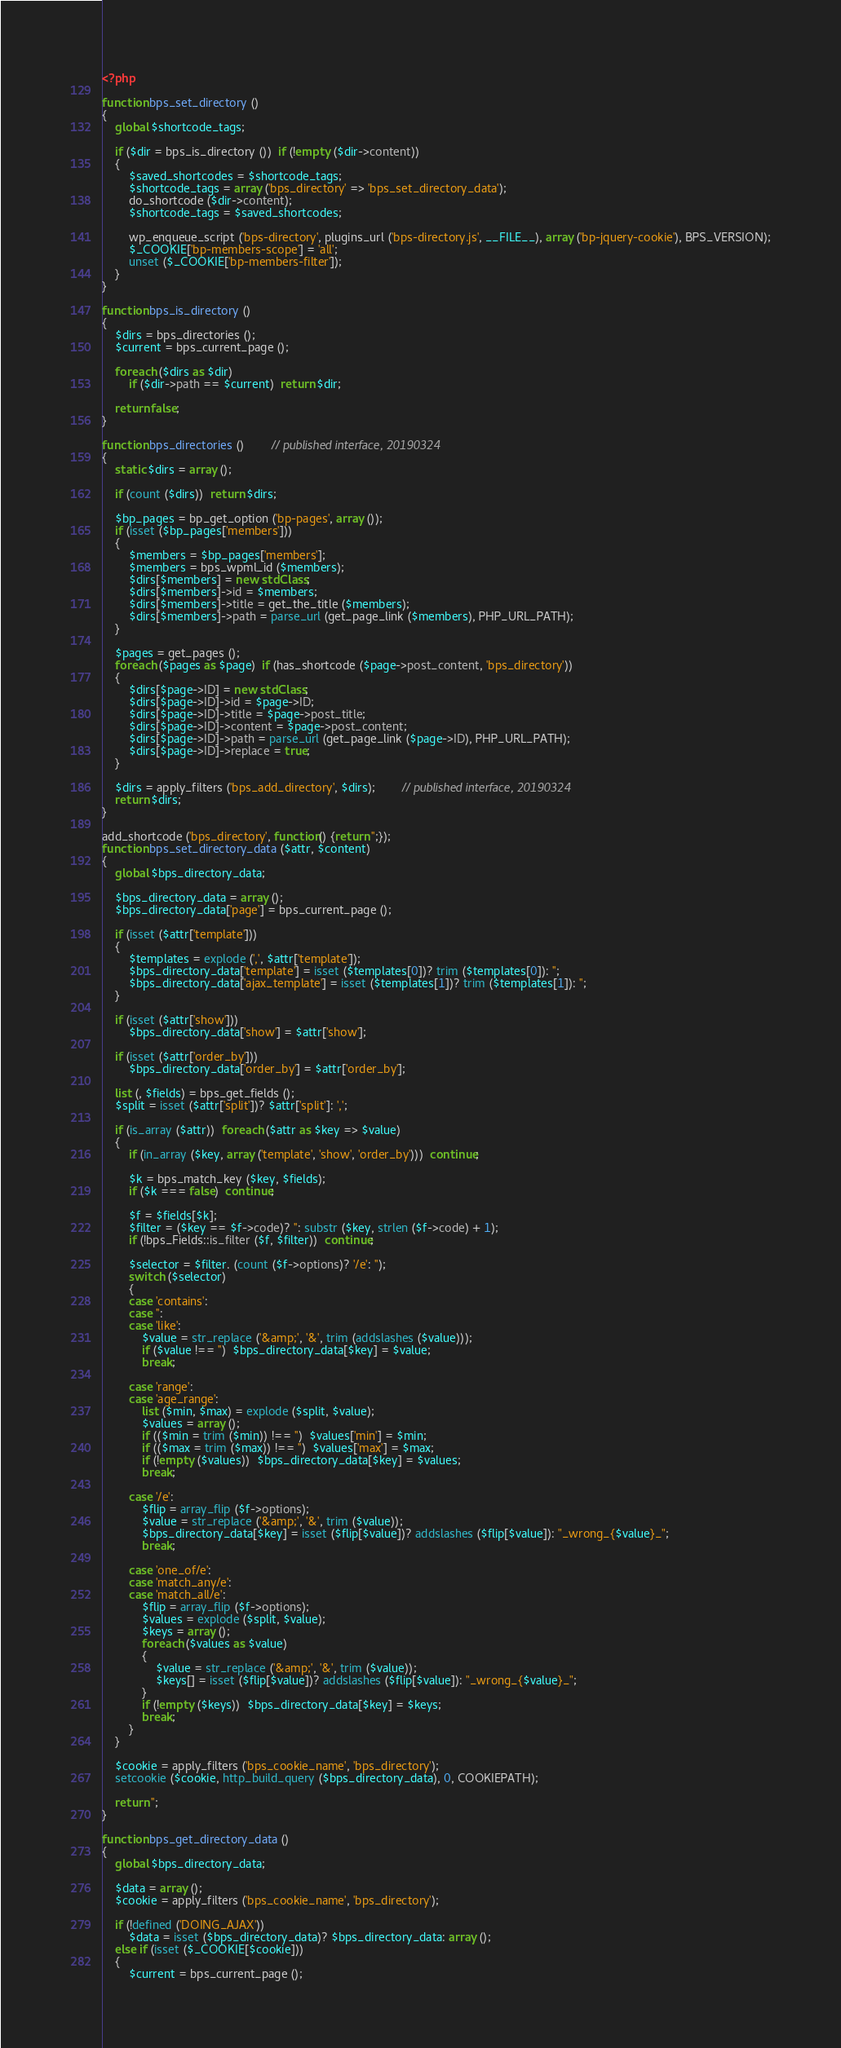Convert code to text. <code><loc_0><loc_0><loc_500><loc_500><_PHP_><?php

function bps_set_directory ()
{
	global $shortcode_tags;

	if ($dir = bps_is_directory ())  if (!empty ($dir->content))
	{
		$saved_shortcodes = $shortcode_tags;
		$shortcode_tags = array ('bps_directory' => 'bps_set_directory_data');
		do_shortcode ($dir->content);
		$shortcode_tags = $saved_shortcodes;

		wp_enqueue_script ('bps-directory', plugins_url ('bps-directory.js', __FILE__), array ('bp-jquery-cookie'), BPS_VERSION);
		$_COOKIE['bp-members-scope'] = 'all';
		unset ($_COOKIE['bp-members-filter']);
	}
}

function bps_is_directory ()
{
	$dirs = bps_directories ();
	$current = bps_current_page ();

	foreach ($dirs as $dir)
		if ($dir->path == $current)  return $dir;

	return false;
}

function bps_directories ()		// published interface, 20190324
{
	static $dirs = array ();

	if (count ($dirs))  return $dirs;

	$bp_pages = bp_get_option ('bp-pages', array ());
	if (isset ($bp_pages['members']))
	{
		$members = $bp_pages['members'];
		$members = bps_wpml_id ($members);
		$dirs[$members] = new stdClass;
		$dirs[$members]->id = $members;
		$dirs[$members]->title = get_the_title ($members);
		$dirs[$members]->path = parse_url (get_page_link ($members), PHP_URL_PATH);
	}

	$pages = get_pages ();
	foreach ($pages as $page)  if (has_shortcode ($page->post_content, 'bps_directory'))
	{
		$dirs[$page->ID] = new stdClass;
		$dirs[$page->ID]->id = $page->ID;
		$dirs[$page->ID]->title = $page->post_title;
		$dirs[$page->ID]->content = $page->post_content;
		$dirs[$page->ID]->path = parse_url (get_page_link ($page->ID), PHP_URL_PATH);
		$dirs[$page->ID]->replace = true;
	}

	$dirs = apply_filters ('bps_add_directory', $dirs);		// published interface, 20190324
	return $dirs;
}

add_shortcode ('bps_directory', function() {return '';});
function bps_set_directory_data ($attr, $content)
{
	global $bps_directory_data;

	$bps_directory_data = array ();
	$bps_directory_data['page'] = bps_current_page ();

	if (isset ($attr['template']))
	{
		$templates = explode (',', $attr['template']);
		$bps_directory_data['template'] = isset ($templates[0])? trim ($templates[0]): '';
		$bps_directory_data['ajax_template'] = isset ($templates[1])? trim ($templates[1]): '';
	}

	if (isset ($attr['show']))
		$bps_directory_data['show'] = $attr['show'];

	if (isset ($attr['order_by']))
		$bps_directory_data['order_by'] = $attr['order_by'];

	list (, $fields) = bps_get_fields ();
	$split = isset ($attr['split'])? $attr['split']: ',';

	if (is_array ($attr))  foreach ($attr as $key => $value)
	{
		if (in_array ($key, array ('template', 'show', 'order_by')))  continue;

		$k = bps_match_key ($key, $fields);
		if ($k === false)  continue;

		$f = $fields[$k];
		$filter = ($key == $f->code)? '': substr ($key, strlen ($f->code) + 1);
		if (!bps_Fields::is_filter ($f, $filter))  continue;

		$selector = $filter. (count ($f->options)? '/e': '');
		switch ($selector)
		{
		case 'contains':
		case '':
		case 'like':
			$value = str_replace ('&amp;', '&', trim (addslashes ($value)));
			if ($value !== '')  $bps_directory_data[$key] = $value;
			break;

		case 'range':
		case 'age_range':
			list ($min, $max) = explode ($split, $value);
			$values = array ();
			if (($min = trim ($min)) !== '')  $values['min'] = $min;
			if (($max = trim ($max)) !== '')  $values['max'] = $max;
			if (!empty ($values))  $bps_directory_data[$key] = $values;
			break;

		case '/e':
			$flip = array_flip ($f->options);
			$value = str_replace ('&amp;', '&', trim ($value));
			$bps_directory_data[$key] = isset ($flip[$value])? addslashes ($flip[$value]): "_wrong_{$value}_";
			break;

		case 'one_of/e':
		case 'match_any/e':
		case 'match_all/e':
			$flip = array_flip ($f->options);
			$values = explode ($split, $value);
			$keys = array ();
			foreach ($values as $value)
			{
				$value = str_replace ('&amp;', '&', trim ($value));
				$keys[] = isset ($flip[$value])? addslashes ($flip[$value]): "_wrong_{$value}_";
			}
			if (!empty ($keys))  $bps_directory_data[$key] = $keys;
			break;
		}
	}

	$cookie = apply_filters ('bps_cookie_name', 'bps_directory');
	setcookie ($cookie, http_build_query ($bps_directory_data), 0, COOKIEPATH);

	return '';
}

function bps_get_directory_data ()
{
	global $bps_directory_data;

	$data = array ();
	$cookie = apply_filters ('bps_cookie_name', 'bps_directory');

	if (!defined ('DOING_AJAX'))
		$data = isset ($bps_directory_data)? $bps_directory_data: array ();
	else if (isset ($_COOKIE[$cookie]))
	{
		$current = bps_current_page ();</code> 